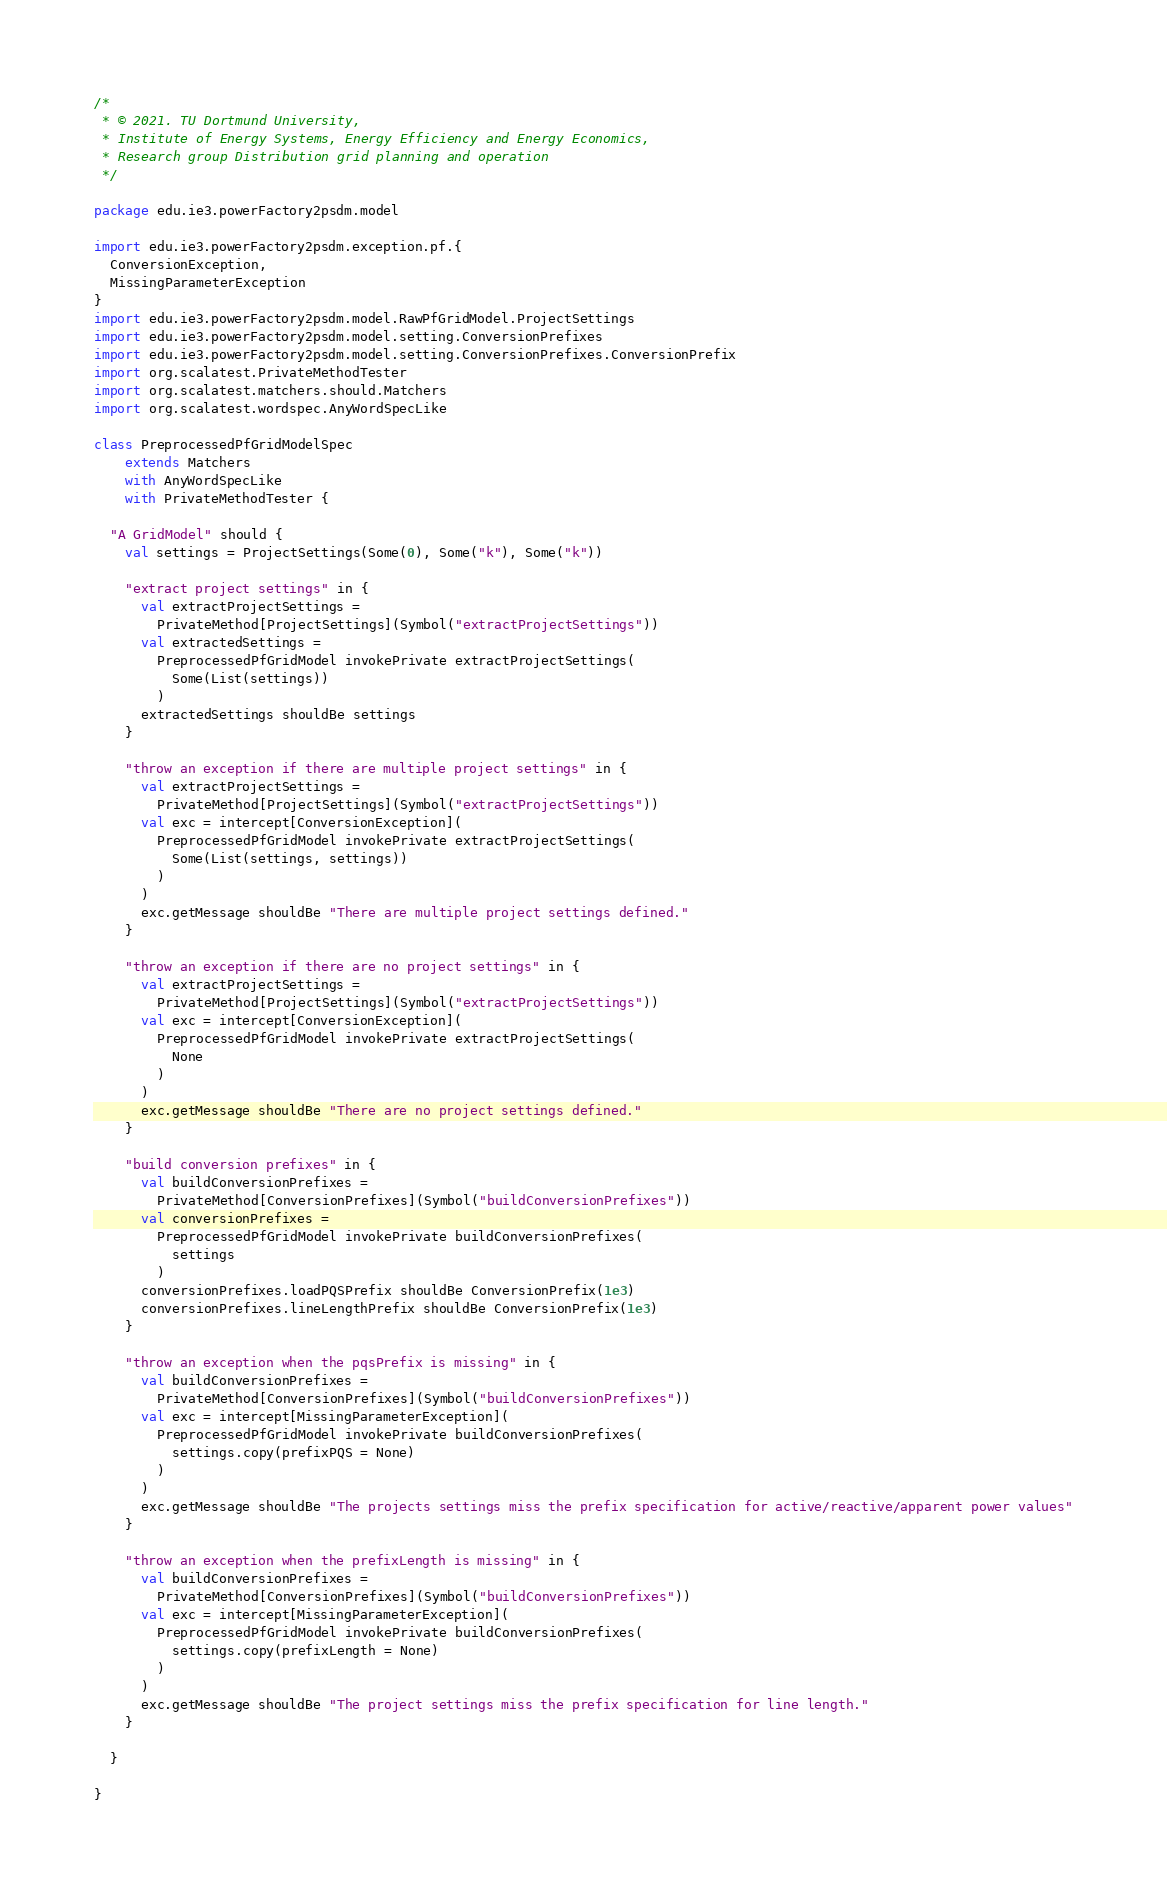Convert code to text. <code><loc_0><loc_0><loc_500><loc_500><_Scala_>/*
 * © 2021. TU Dortmund University,
 * Institute of Energy Systems, Energy Efficiency and Energy Economics,
 * Research group Distribution grid planning and operation
 */

package edu.ie3.powerFactory2psdm.model

import edu.ie3.powerFactory2psdm.exception.pf.{
  ConversionException,
  MissingParameterException
}
import edu.ie3.powerFactory2psdm.model.RawPfGridModel.ProjectSettings
import edu.ie3.powerFactory2psdm.model.setting.ConversionPrefixes
import edu.ie3.powerFactory2psdm.model.setting.ConversionPrefixes.ConversionPrefix
import org.scalatest.PrivateMethodTester
import org.scalatest.matchers.should.Matchers
import org.scalatest.wordspec.AnyWordSpecLike

class PreprocessedPfGridModelSpec
    extends Matchers
    with AnyWordSpecLike
    with PrivateMethodTester {

  "A GridModel" should {
    val settings = ProjectSettings(Some(0), Some("k"), Some("k"))

    "extract project settings" in {
      val extractProjectSettings =
        PrivateMethod[ProjectSettings](Symbol("extractProjectSettings"))
      val extractedSettings =
        PreprocessedPfGridModel invokePrivate extractProjectSettings(
          Some(List(settings))
        )
      extractedSettings shouldBe settings
    }

    "throw an exception if there are multiple project settings" in {
      val extractProjectSettings =
        PrivateMethod[ProjectSettings](Symbol("extractProjectSettings"))
      val exc = intercept[ConversionException](
        PreprocessedPfGridModel invokePrivate extractProjectSettings(
          Some(List(settings, settings))
        )
      )
      exc.getMessage shouldBe "There are multiple project settings defined."
    }

    "throw an exception if there are no project settings" in {
      val extractProjectSettings =
        PrivateMethod[ProjectSettings](Symbol("extractProjectSettings"))
      val exc = intercept[ConversionException](
        PreprocessedPfGridModel invokePrivate extractProjectSettings(
          None
        )
      )
      exc.getMessage shouldBe "There are no project settings defined."
    }

    "build conversion prefixes" in {
      val buildConversionPrefixes =
        PrivateMethod[ConversionPrefixes](Symbol("buildConversionPrefixes"))
      val conversionPrefixes =
        PreprocessedPfGridModel invokePrivate buildConversionPrefixes(
          settings
        )
      conversionPrefixes.loadPQSPrefix shouldBe ConversionPrefix(1e3)
      conversionPrefixes.lineLengthPrefix shouldBe ConversionPrefix(1e3)
    }

    "throw an exception when the pqsPrefix is missing" in {
      val buildConversionPrefixes =
        PrivateMethod[ConversionPrefixes](Symbol("buildConversionPrefixes"))
      val exc = intercept[MissingParameterException](
        PreprocessedPfGridModel invokePrivate buildConversionPrefixes(
          settings.copy(prefixPQS = None)
        )
      )
      exc.getMessage shouldBe "The projects settings miss the prefix specification for active/reactive/apparent power values"
    }

    "throw an exception when the prefixLength is missing" in {
      val buildConversionPrefixes =
        PrivateMethod[ConversionPrefixes](Symbol("buildConversionPrefixes"))
      val exc = intercept[MissingParameterException](
        PreprocessedPfGridModel invokePrivate buildConversionPrefixes(
          settings.copy(prefixLength = None)
        )
      )
      exc.getMessage shouldBe "The project settings miss the prefix specification for line length."
    }

  }

}
</code> 